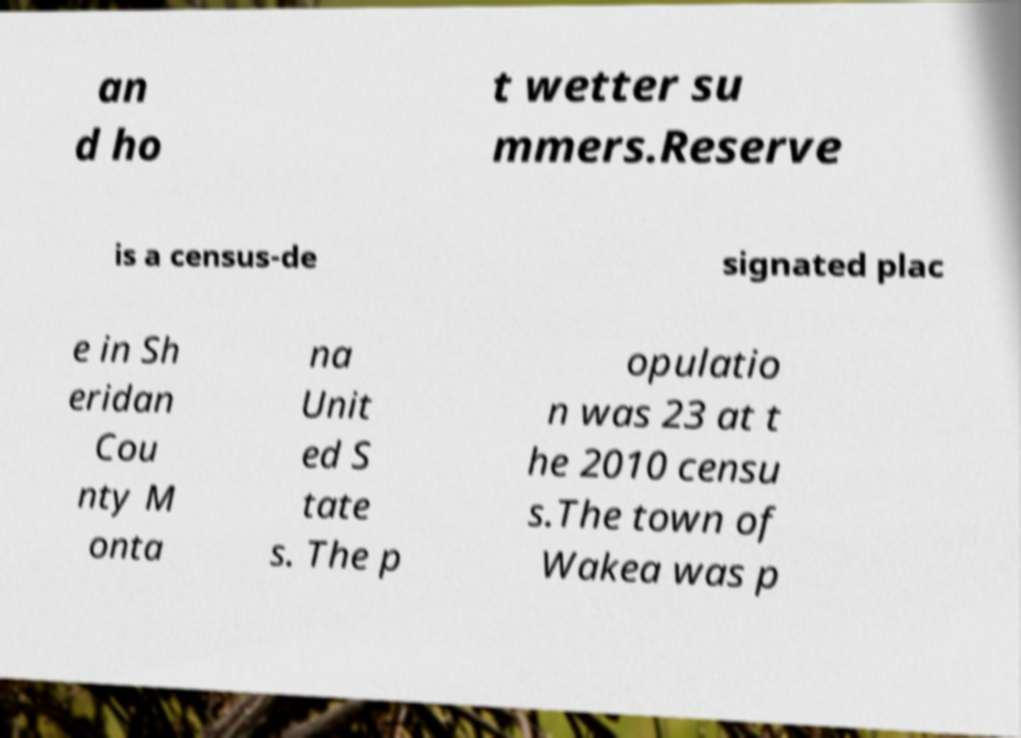Can you accurately transcribe the text from the provided image for me? an d ho t wetter su mmers.Reserve is a census-de signated plac e in Sh eridan Cou nty M onta na Unit ed S tate s. The p opulatio n was 23 at t he 2010 censu s.The town of Wakea was p 